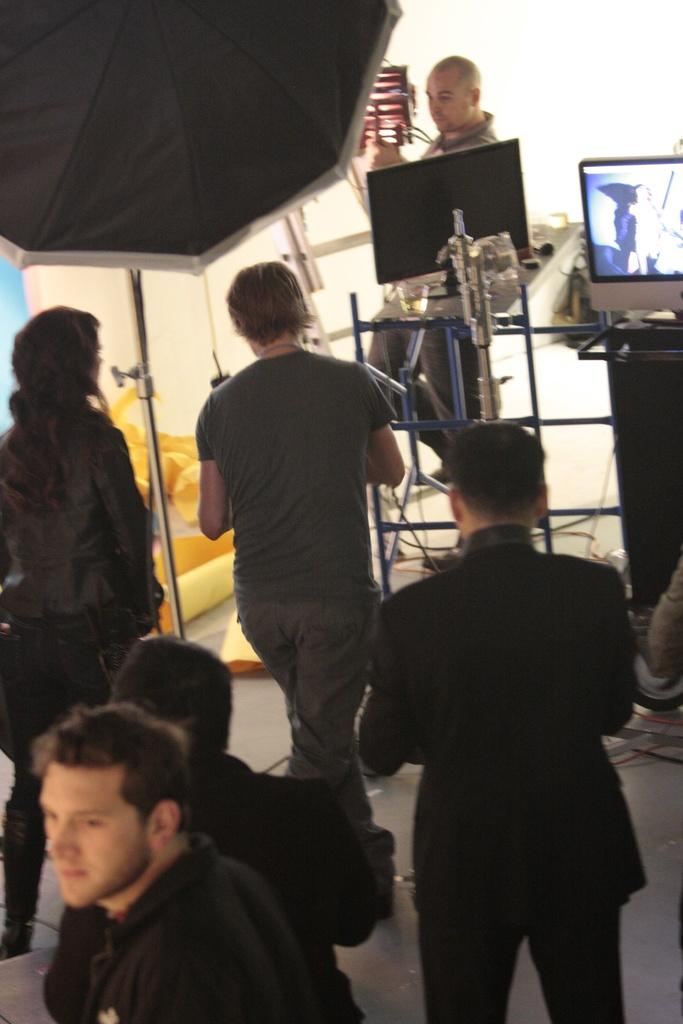How many individuals are present in the image? There are many people in the image. What are the people wearing? The people are wearing clothes. Can you describe any specific object in the image? There is an umbrella in the image. What is the surface that the people and objects are standing on? There is a floor in the image. Are there any visible wires in the image? Yes, cable wires are present in the image. What is the purpose of the screen in the image? The purpose of the screen is not specified in the provided facts. What type of support can be seen in the image? There is no specific support structure mentioned in the provided facts. What is the scale of the image? The scale of the image is not mentioned in the provided facts. 